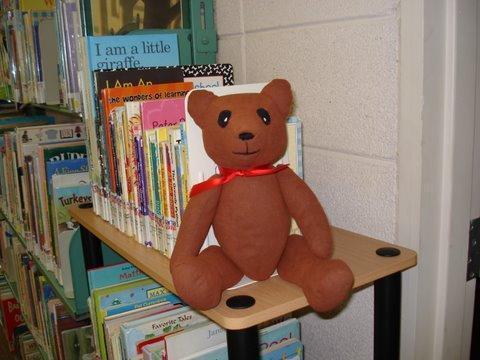How many teddy bears are in the photo?
Give a very brief answer. 1. How many books are in the picture?
Give a very brief answer. 6. How many people are in this photo?
Give a very brief answer. 0. 